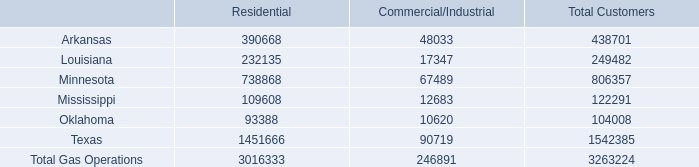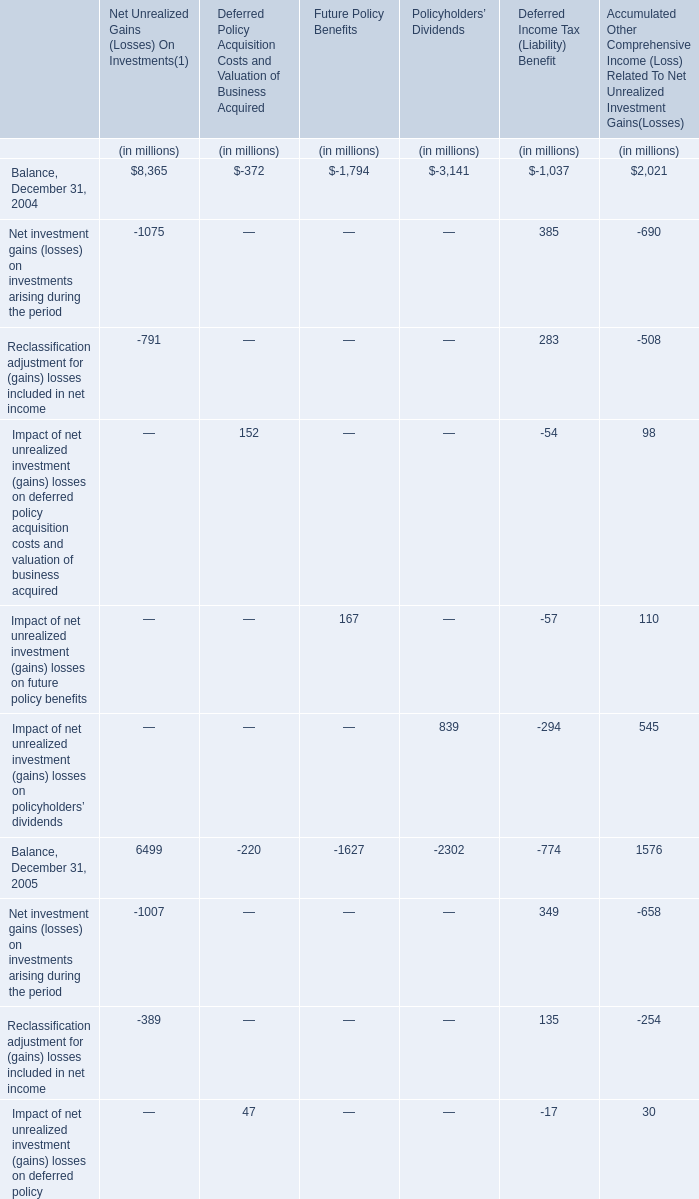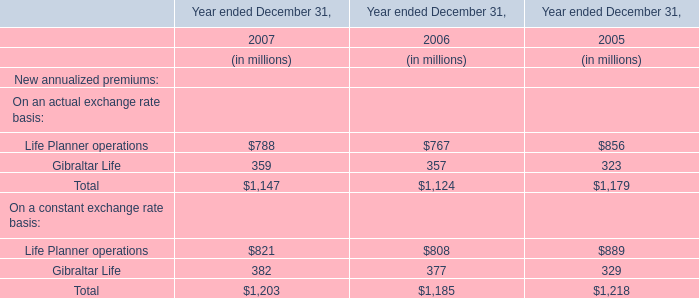What do all elements sum up, excluding those negative ones for Deferred Policy Acquisition Costs and Valuation of Business Acquired? (in million) 
Computations: ((152 + 47) + 55)
Answer: 254.0. 